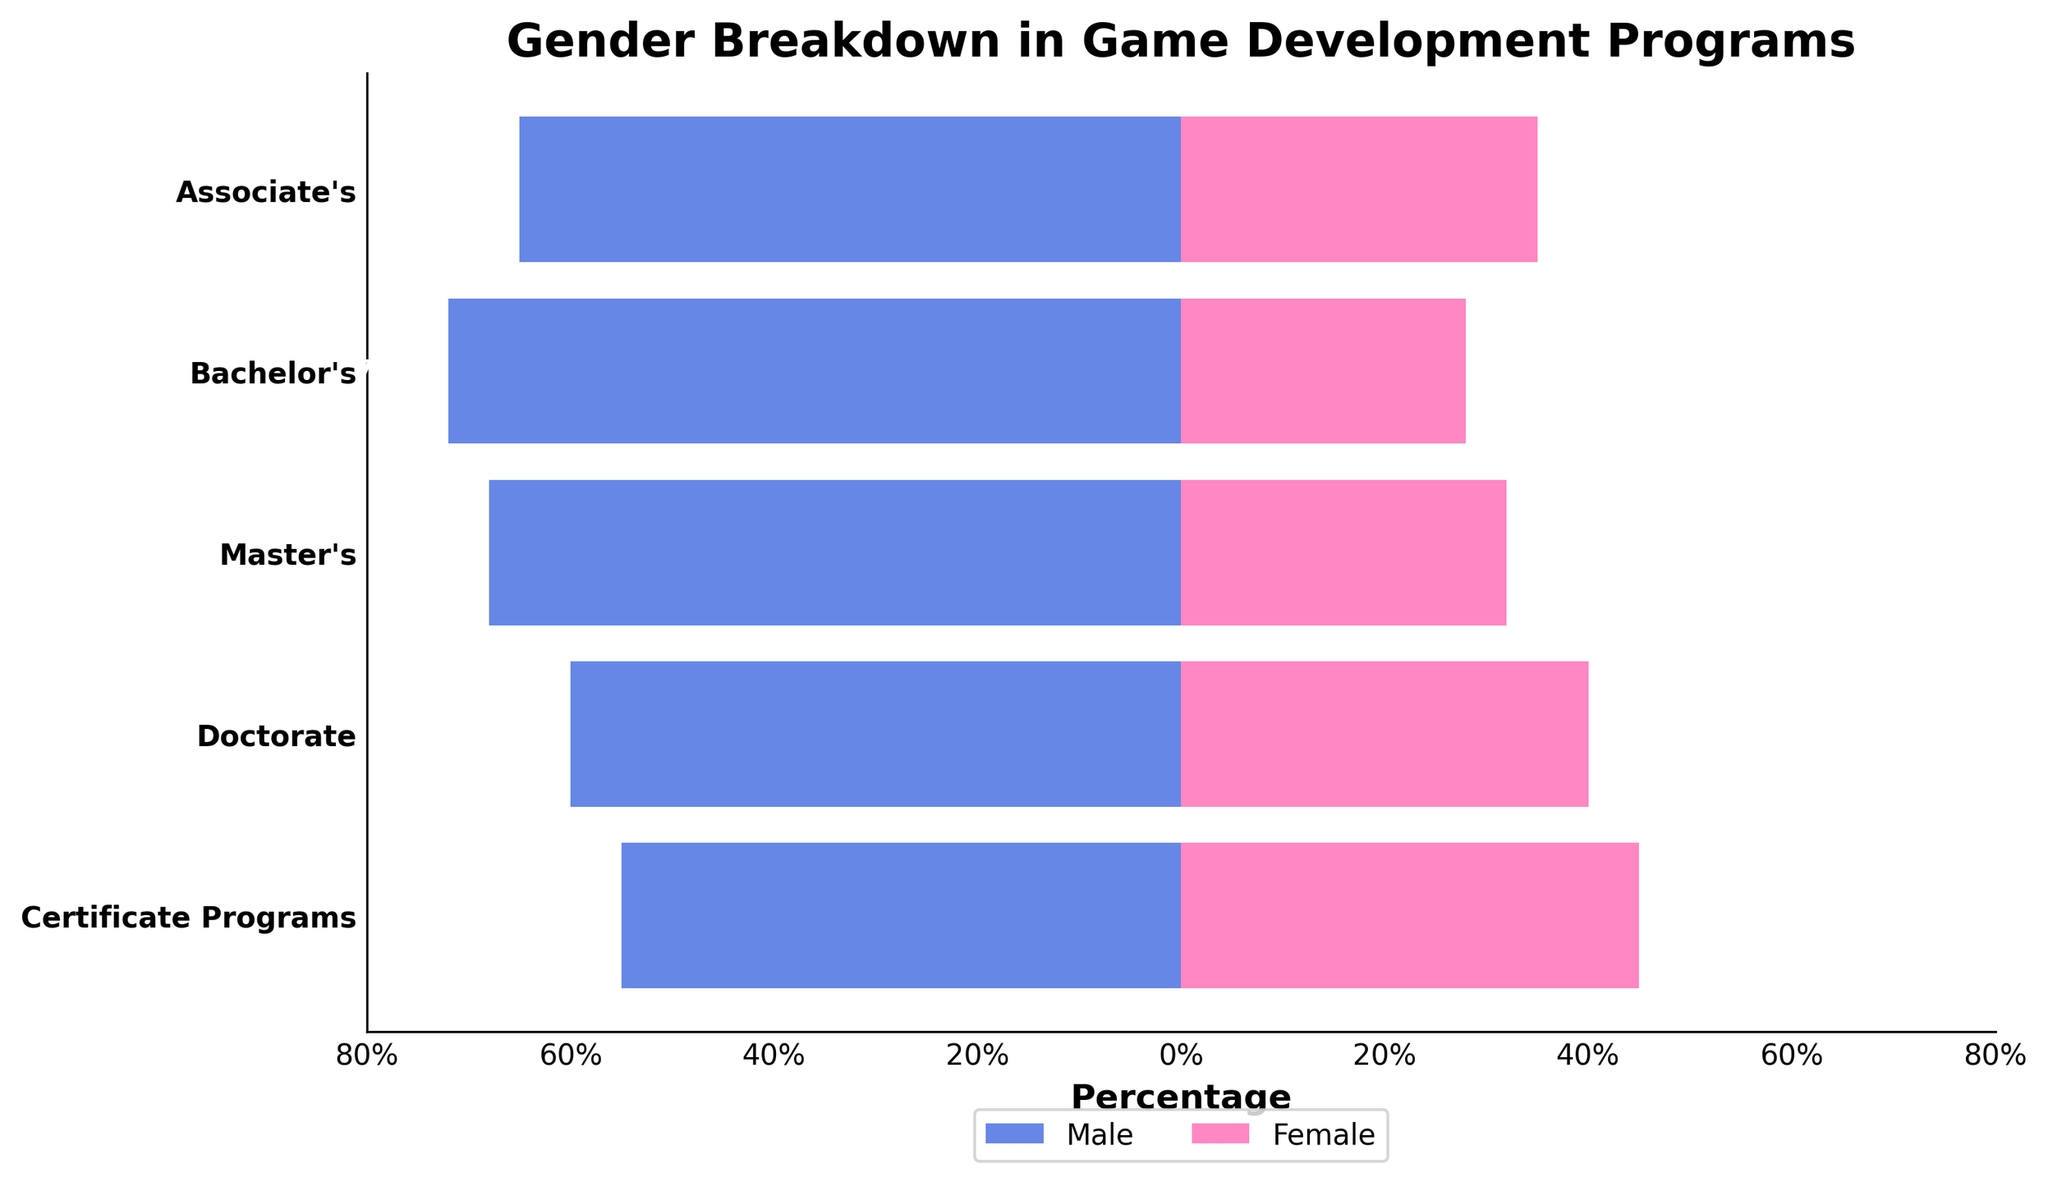What's the title of the figure? The title of the figure is clearly written at the top of the plot. It reads "Gender Breakdown in Game Development Programs".
Answer: Gender Breakdown in Game Development Programs How many degree levels are represented in the figure? The y-axis lists all the degree levels, including Associate's, Bachelor's, Master's, Doctorate, and Certificate Programs. Counting them gives us five in total.
Answer: 5 Which degree level has the highest percentage of male students? By examining the length of the bars on the male side (left side with negative values), Bachelor's has the longest bar indicating the highest percentage at 72%.
Answer: Bachelor's What is the percentage difference between male and female students in Doctorate programs? For Doctorate programs, the male percentage is 60%, and the female percentage is 40%. The difference is calculated as 60% - 40% = 20%.
Answer: 20% Which degree level shows the least gender disparity? Gender disparity is smallest where the male and female percentages are closest. For Certificate Programs, the male percentage is 55% and the female percentage is 45%, leading to a disparity of 10%. Other degree levels have larger disparities.
Answer: Certificate Programs What percentage of students in Bachelor's programs are female? The bar corresponding to female students in Bachelor's programs has a value of 28%.
Answer: 28% Compare the percentage of female students in Associate's and Master's programs. Which one has a higher percentage, and by how much? The percentage of female students in Associate's programs is 35%, while in Master's programs it is 32%. Associate's has a higher percentage by 35% - 32% = 3%.
Answer: Associate's, 3% In which degree level is the male percentage closest to 60%? Checking the bars for the male side, both Doctorate and Certificate Programs are close to 60%, with Doctorate exactly at 60%.
Answer: Doctorate If you combine the male and female percentages for Associate's and Master's programs, which one has the larger combined percentage, and by how much? Summing the male and female percentages for each: Associate's: 65% + 35% = 100%, Master's: 68% + 32% = 100%. Both total to 100%, so the difference is 0%.
Answer: Equal, 0% Which degree level has the smallest percentage of female students? Examining the female bars, Bachelor's has the shortest bar at 28%, indicating it is the smallest percentage.
Answer: Bachelor's 